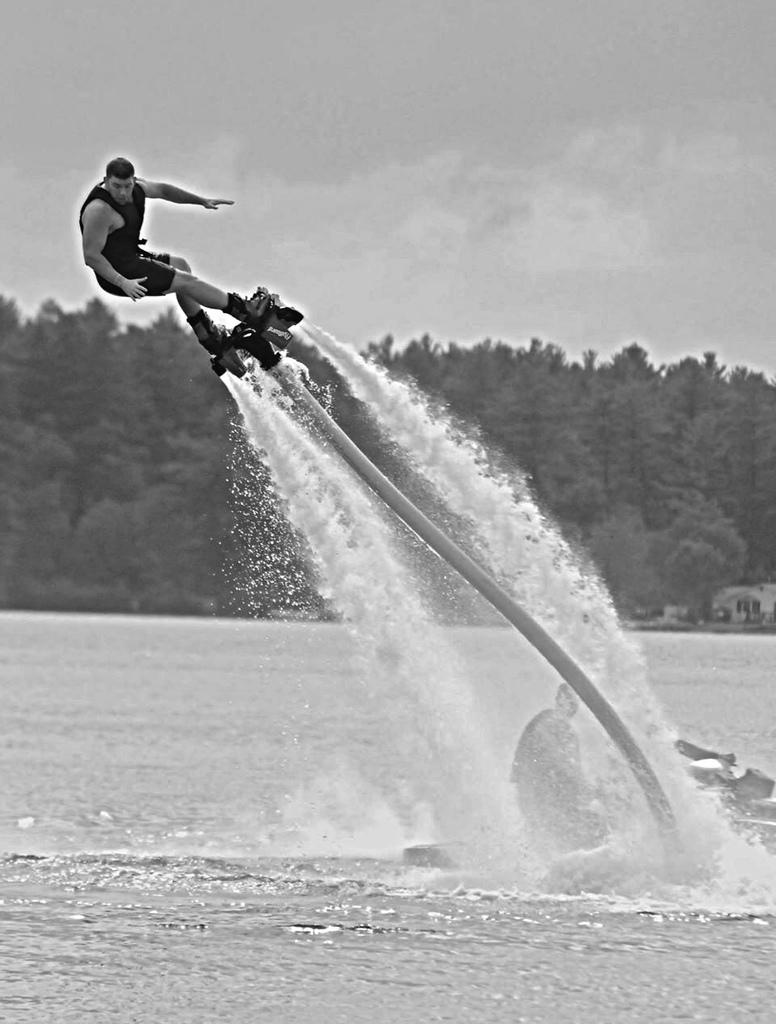What is the man in the foreground of the image doing? The man is on a fly board in the foreground of the image. What else can be seen in the foreground of the image? There is a boat in the water, and a man is on the boat. What is visible in the background of the image? There are trees and the sky visible in the background of the image. What can be observed in the sky? There are clouds in the sky. What type of fruit is being blown by the wind in the image? There is no fruit present in the image, and therefore no such activity can be observed. Can you describe the walk of the man on the boat in the image? There is no indication of the man on the boat walking in the image; he is stationary on the boat. 